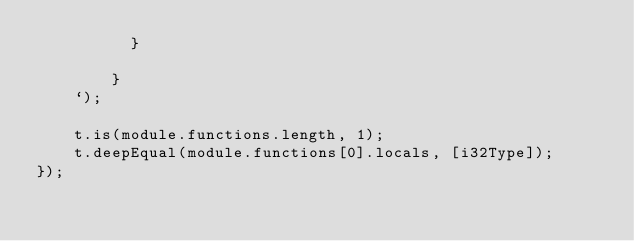Convert code to text. <code><loc_0><loc_0><loc_500><loc_500><_TypeScript_>          }
          
        }
    `);

    t.is(module.functions.length, 1);
    t.deepEqual(module.functions[0].locals, [i32Type]);
});
</code> 